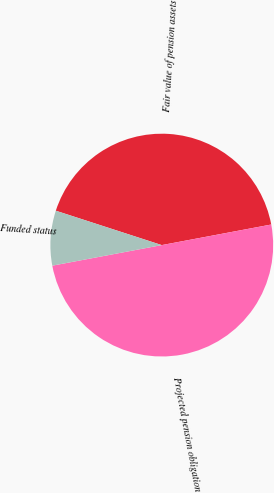Convert chart to OTSL. <chart><loc_0><loc_0><loc_500><loc_500><pie_chart><fcel>Fair value of pension assets<fcel>Projected pension obligation<fcel>Funded status<nl><fcel>42.05%<fcel>50.0%<fcel>7.95%<nl></chart> 